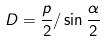<formula> <loc_0><loc_0><loc_500><loc_500>D = \frac { p } { 2 } / \sin \frac { \alpha } { 2 }</formula> 